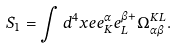<formula> <loc_0><loc_0><loc_500><loc_500>S _ { 1 } = \int d ^ { 4 } x e e _ { K } ^ { \alpha } e _ { L } ^ { \beta + } \Omega _ { \alpha \beta } ^ { K L } .</formula> 